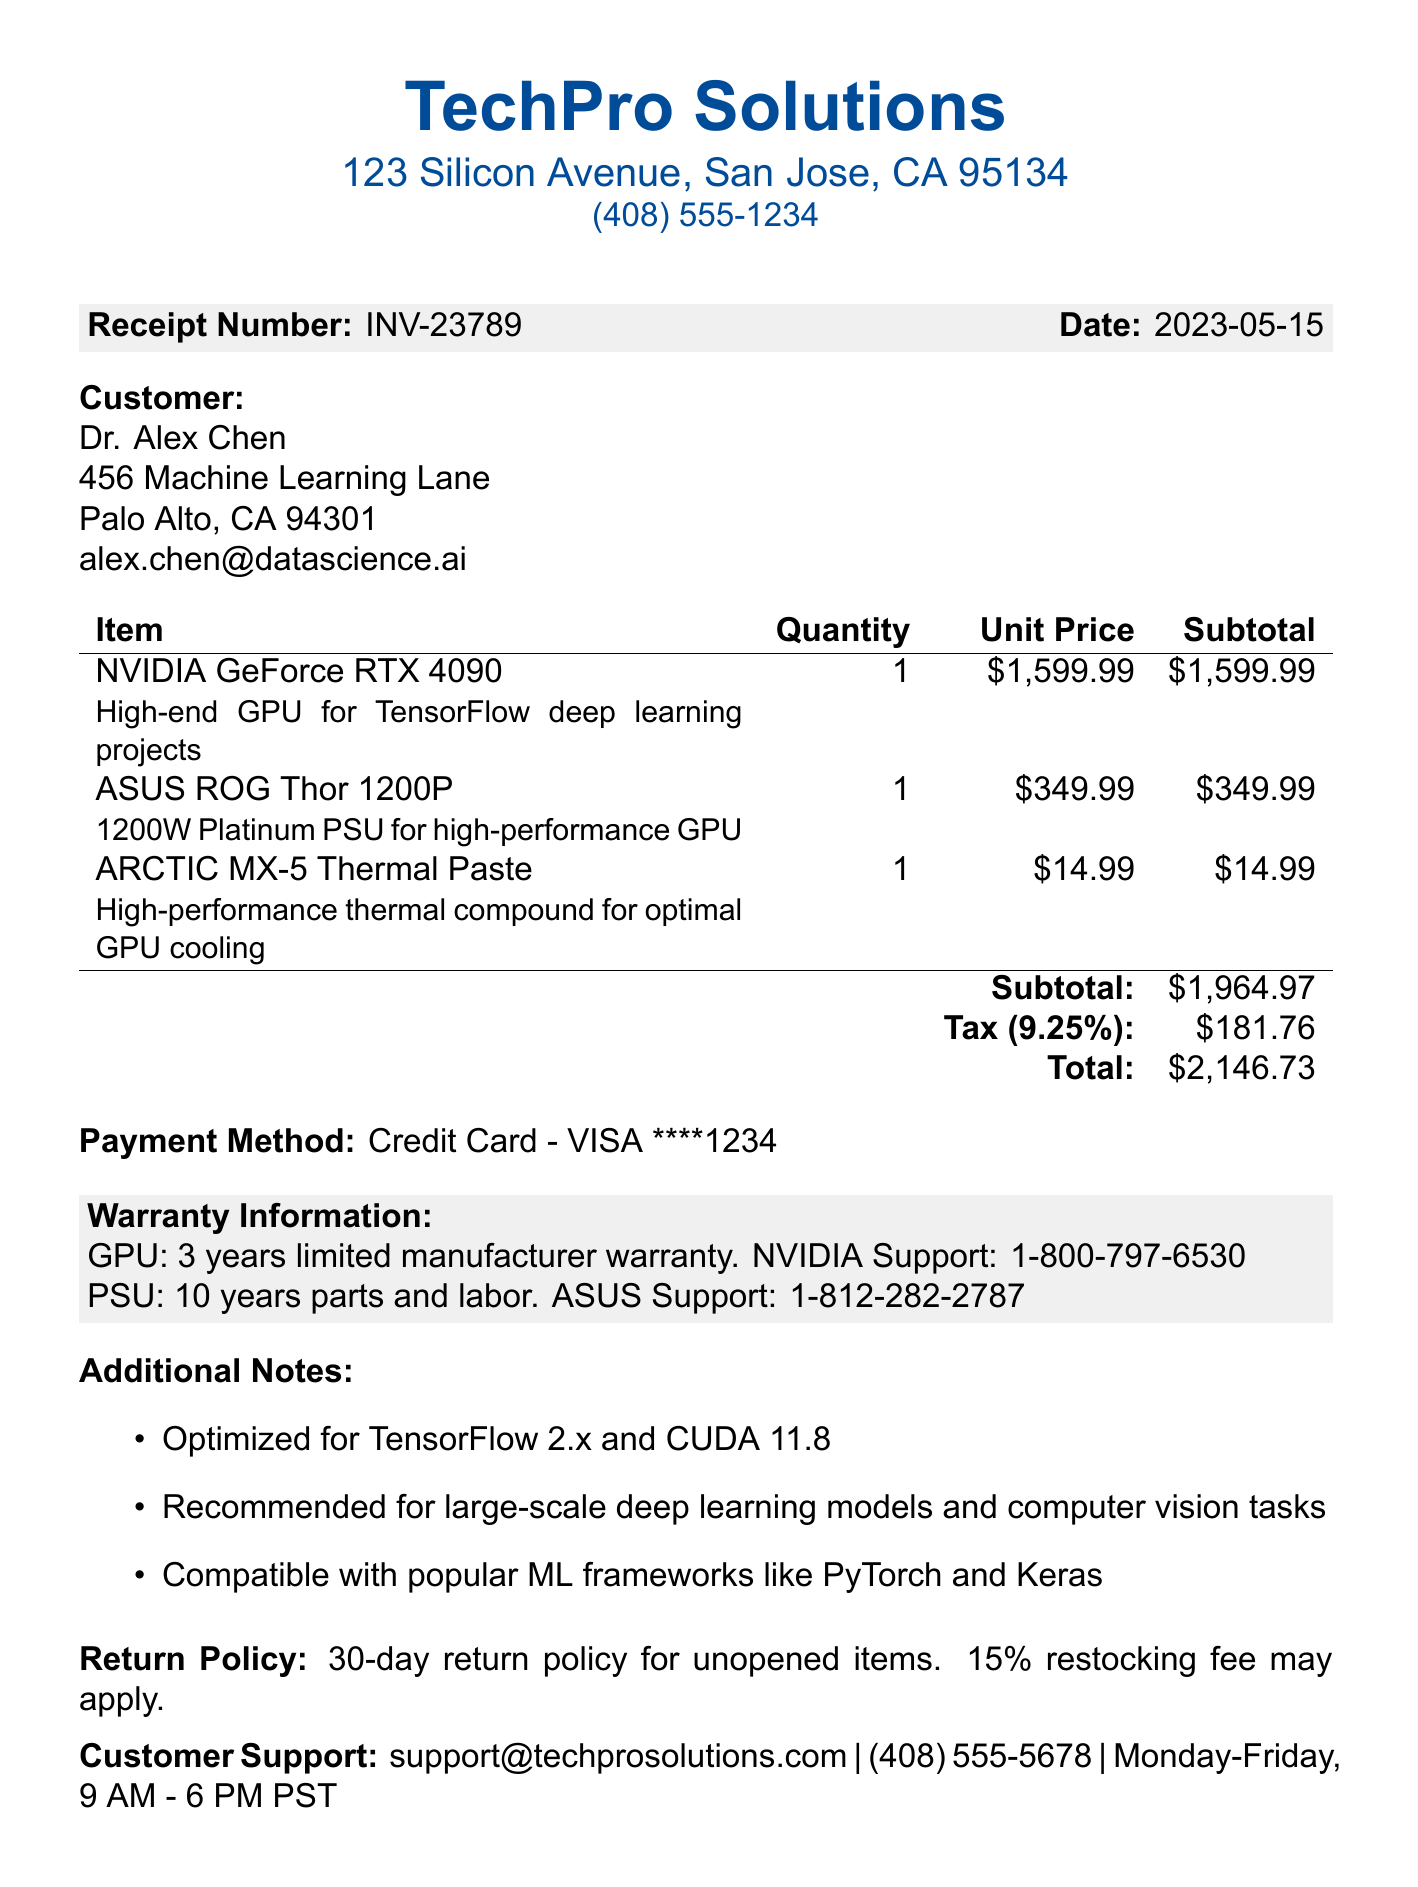What is the receipt number? The receipt number is a unique identifier found in the document, which is INV-23789.
Answer: INV-23789 What is the date of purchase? The date of purchase is listed in the document, which confirms when the transaction occurred, being 2023-05-15.
Answer: 2023-05-15 What is the total cost of the purchase? The total cost is the final amount due after subtotal and tax calculations, which is stated to be $2,146.73.
Answer: $2,146.73 Who is the vendor for this transaction? The vendor name is the company from which the items were purchased, which is TechPro Solutions.
Answer: TechPro Solutions What is the warranty duration for the GPU? The warranty duration is specified for the GPU, which is 3 years as stated in the warranty information section.
Answer: 3 years What is the subtotal before tax? The subtotal before tax is a key financial figure presented in the document, listed as $1,964.97.
Answer: $1,964.97 What is the tax rate applied in this transaction? The tax rate is shown as a percentage that was added to the subtotal, which is 9.25%.
Answer: 9.25% Under what conditions can items be returned? The return policy details the conditions under which items can be returned, specifying a 30-day return policy for unopened items.
Answer: 30-day return policy for unopened items Which payment method was used? The payment method is the means by which the transaction was completed, indicated as a Credit Card - VISA.
Answer: Credit Card - VISA ****1234 